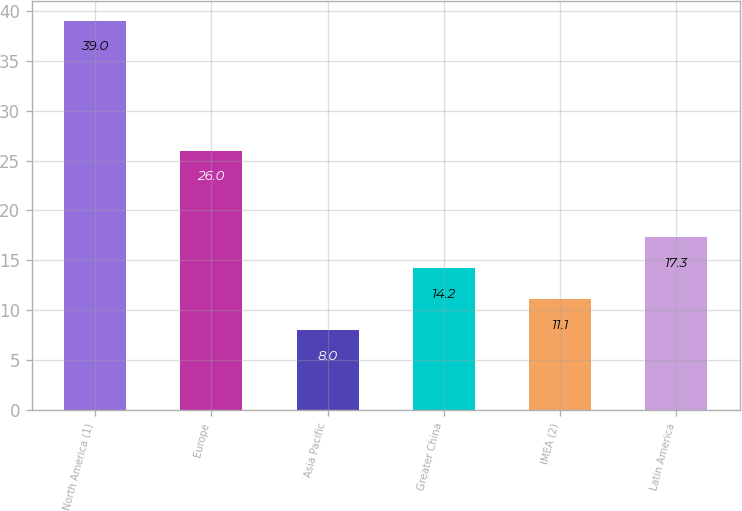Convert chart. <chart><loc_0><loc_0><loc_500><loc_500><bar_chart><fcel>North America (1)<fcel>Europe<fcel>Asia Pacific<fcel>Greater China<fcel>IMEA (2)<fcel>Latin America<nl><fcel>39<fcel>26<fcel>8<fcel>14.2<fcel>11.1<fcel>17.3<nl></chart> 